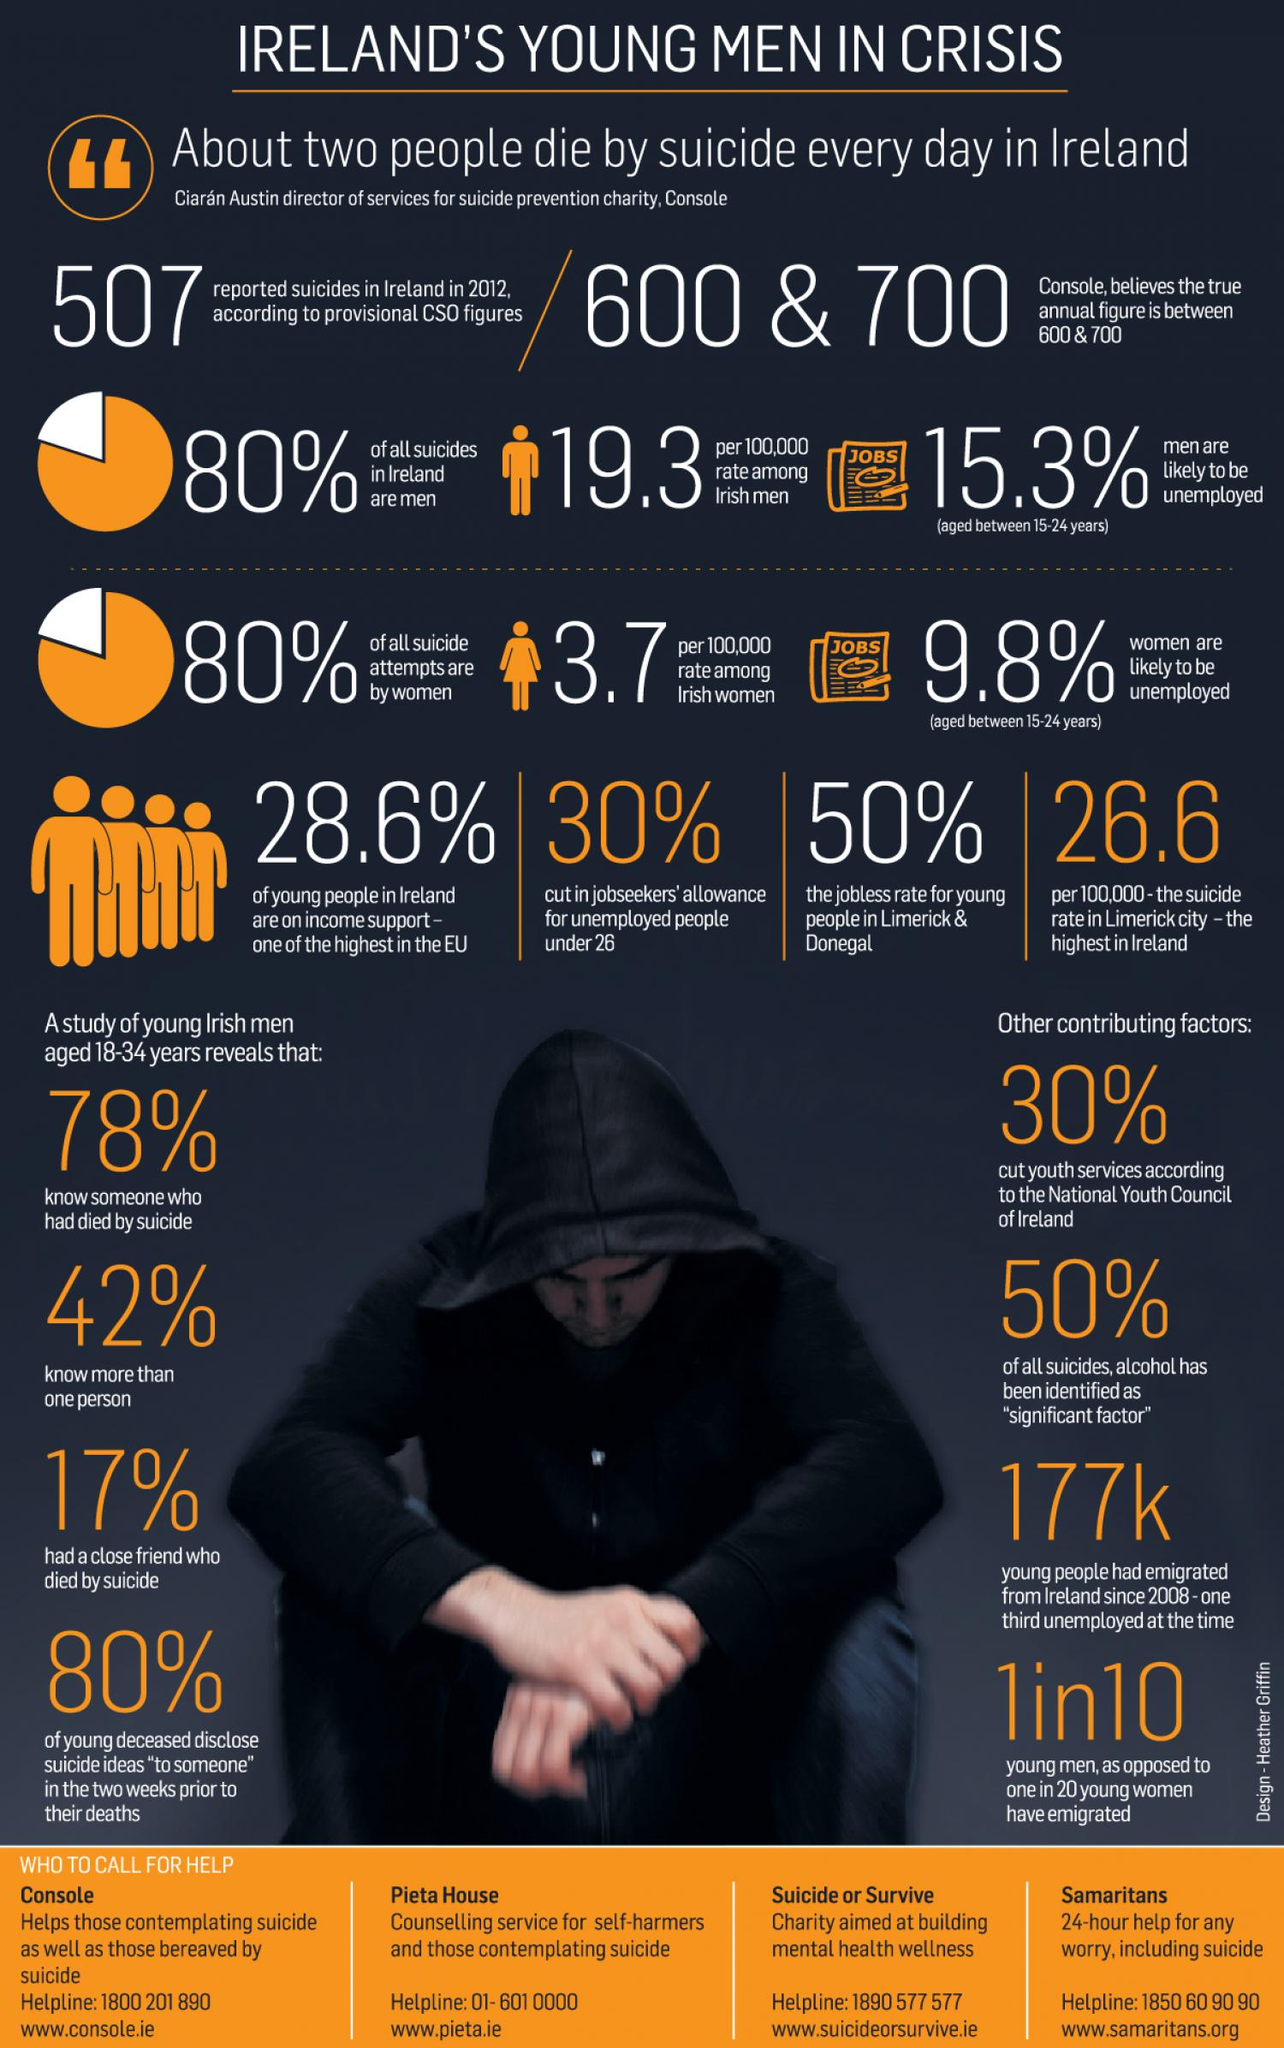Identify some key points in this picture. In approximately half of all suicides in Ireland, alcohol has been identified as a significant factor, according to recent data. According to information obtained, jobseekers' allowance for unemployed individuals under the age of 26 in Ireland has been reduced by 30 percent. Eighty percent of all suicides in Ireland are committed by men. The suicide rate in the Limerick city of Ireland is 26.6 per million population. According to the data, since 2008, a total of 177,000 young people have emigrated from Ireland. 